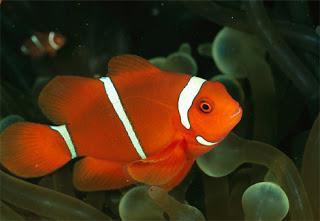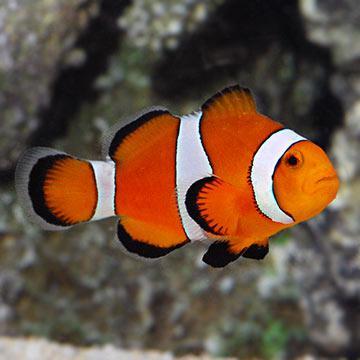The first image is the image on the left, the second image is the image on the right. Analyze the images presented: Is the assertion "The images show a total of two orange-faced fish swimming rightward." valid? Answer yes or no. Yes. 